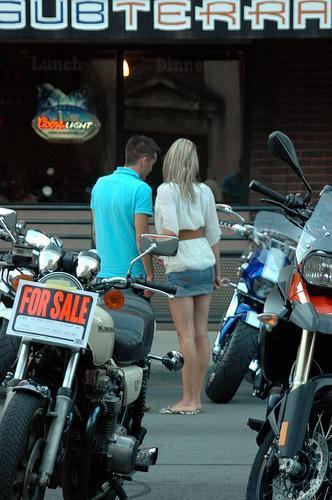How many people in the photo?
Give a very brief answer. 2. 